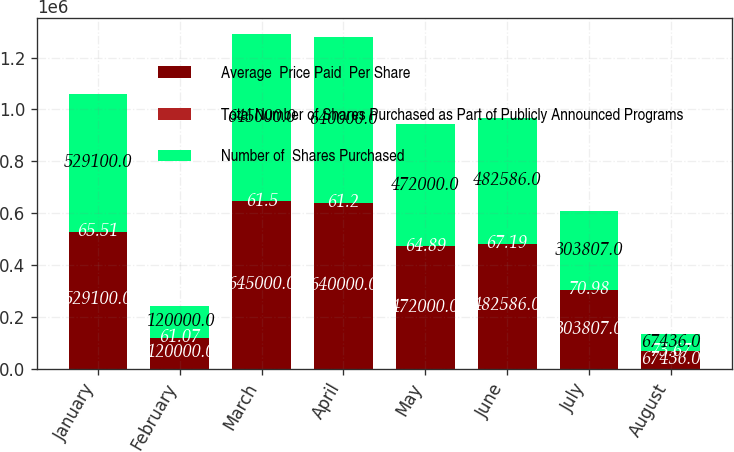Convert chart. <chart><loc_0><loc_0><loc_500><loc_500><stacked_bar_chart><ecel><fcel>January<fcel>February<fcel>March<fcel>April<fcel>May<fcel>June<fcel>July<fcel>August<nl><fcel>Average  Price Paid  Per Share<fcel>529100<fcel>120000<fcel>645000<fcel>640000<fcel>472000<fcel>482586<fcel>303807<fcel>67436<nl><fcel>Total Number of Shares Purchased as Part of Publicly Announced Programs<fcel>65.51<fcel>61.07<fcel>61.5<fcel>61.2<fcel>64.89<fcel>67.19<fcel>70.98<fcel>73.67<nl><fcel>Number of  Shares Purchased<fcel>529100<fcel>120000<fcel>645000<fcel>640000<fcel>472000<fcel>482586<fcel>303807<fcel>67436<nl></chart> 